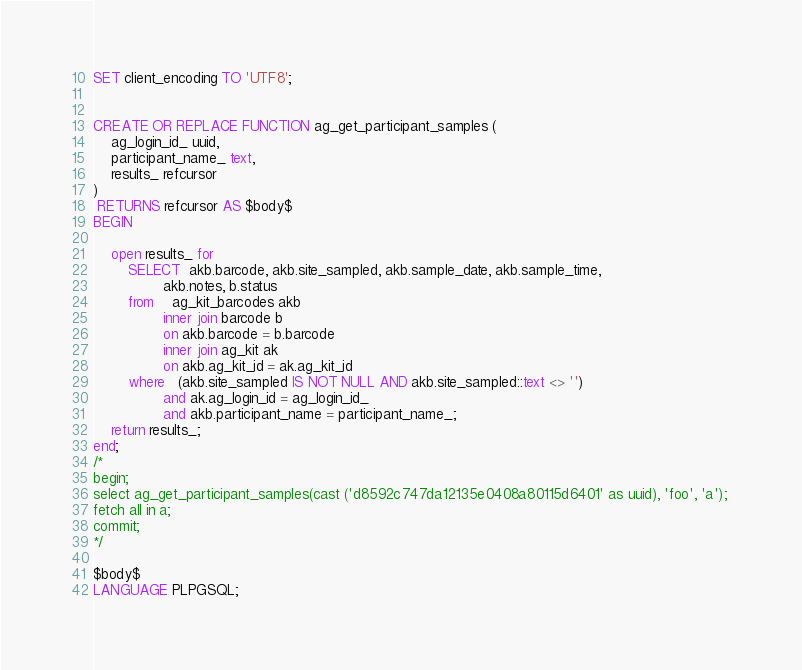Convert code to text. <code><loc_0><loc_0><loc_500><loc_500><_SQL_>SET client_encoding TO 'UTF8';


CREATE OR REPLACE FUNCTION ag_get_participant_samples (
    ag_login_id_ uuid,
    participant_name_ text,
    results_ refcursor
)
 RETURNS refcursor AS $body$
BEGIN

    open results_ for
        SELECT  akb.barcode, akb.site_sampled, akb.sample_date, akb.sample_time, 
                akb.notes, b.status
        from    ag_kit_barcodes akb
                inner join barcode b
                on akb.barcode = b.barcode
                inner join ag_kit ak 
                on akb.ag_kit_id = ak.ag_kit_id 
        where   (akb.site_sampled IS NOT NULL AND akb.site_sampled::text <> '')
                and ak.ag_login_id = ag_login_id_
                and akb.participant_name = participant_name_;
    return results_;            
end;
/*
begin;
select ag_get_participant_samples(cast ('d8592c747da12135e0408a80115d6401' as uuid), 'foo', 'a'); 
fetch all in a;
commit;
*/
 
$body$
LANGUAGE PLPGSQL;




</code> 